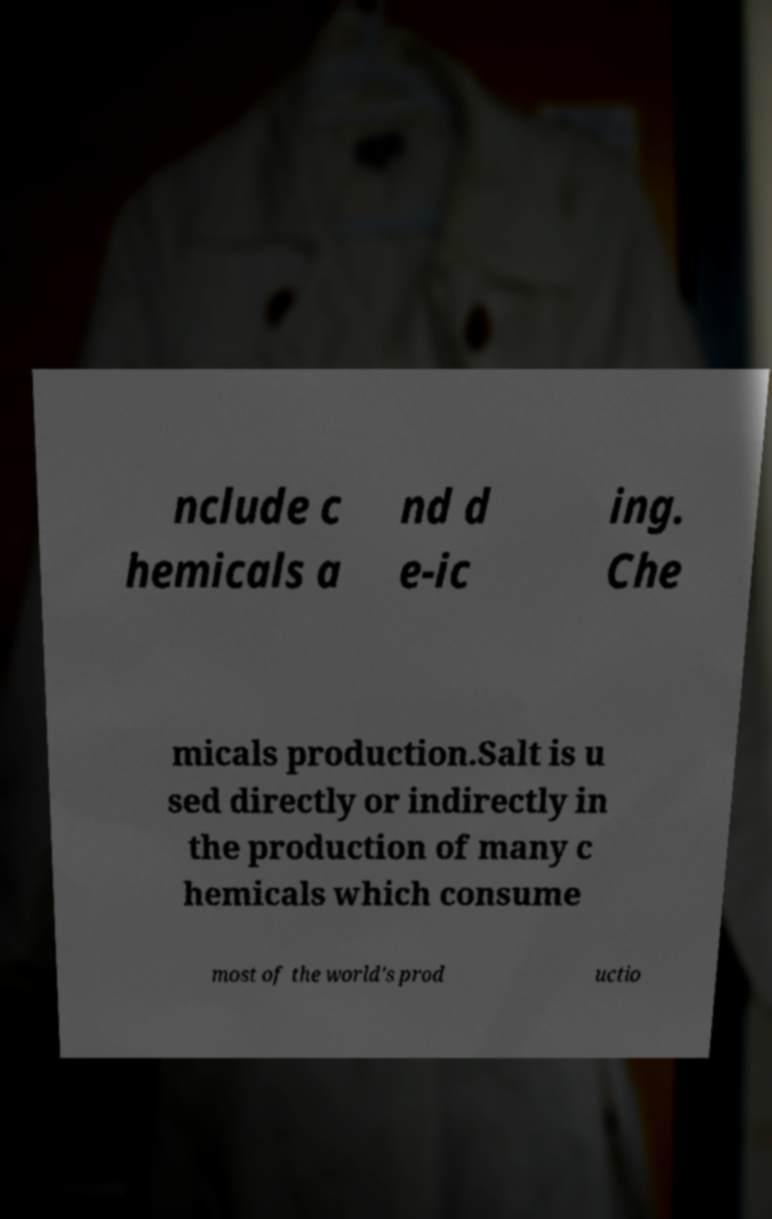Can you accurately transcribe the text from the provided image for me? nclude c hemicals a nd d e-ic ing. Che micals production.Salt is u sed directly or indirectly in the production of many c hemicals which consume most of the world's prod uctio 